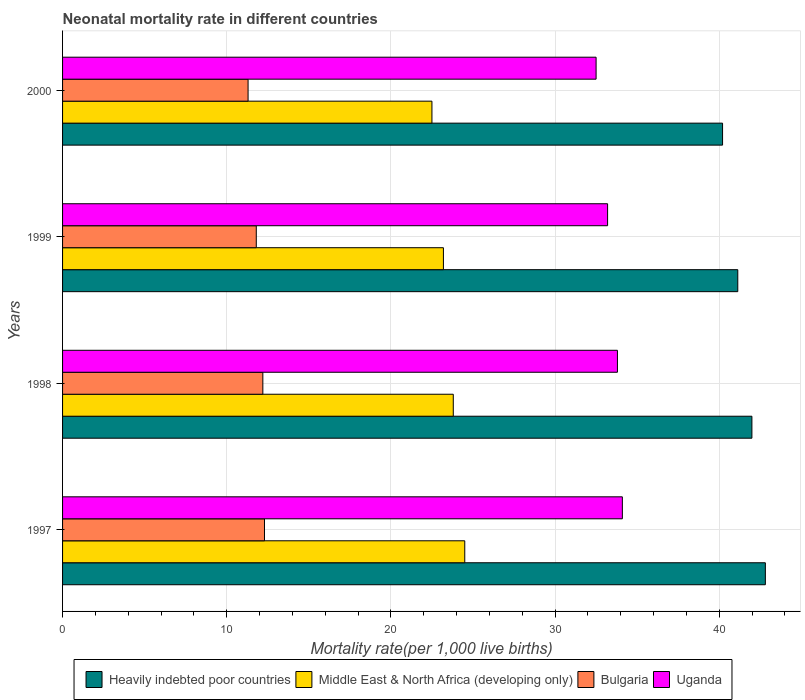Are the number of bars per tick equal to the number of legend labels?
Provide a short and direct response. Yes. Are the number of bars on each tick of the Y-axis equal?
Give a very brief answer. Yes. How many bars are there on the 2nd tick from the top?
Your answer should be compact. 4. How many bars are there on the 1st tick from the bottom?
Your answer should be compact. 4. What is the label of the 1st group of bars from the top?
Offer a terse response. 2000. What is the neonatal mortality rate in Middle East & North Africa (developing only) in 1999?
Make the answer very short. 23.2. Across all years, what is the maximum neonatal mortality rate in Heavily indebted poor countries?
Your answer should be very brief. 42.81. Across all years, what is the minimum neonatal mortality rate in Uganda?
Provide a succinct answer. 32.5. What is the total neonatal mortality rate in Middle East & North Africa (developing only) in the graph?
Ensure brevity in your answer.  94. What is the difference between the neonatal mortality rate in Heavily indebted poor countries in 1997 and that in 1999?
Offer a very short reply. 1.68. What is the difference between the neonatal mortality rate in Middle East & North Africa (developing only) in 1997 and the neonatal mortality rate in Bulgaria in 1999?
Provide a succinct answer. 12.7. What is the average neonatal mortality rate in Middle East & North Africa (developing only) per year?
Your answer should be very brief. 23.5. What is the ratio of the neonatal mortality rate in Middle East & North Africa (developing only) in 1997 to that in 1998?
Your answer should be very brief. 1.03. Is the difference between the neonatal mortality rate in Middle East & North Africa (developing only) in 1998 and 2000 greater than the difference between the neonatal mortality rate in Bulgaria in 1998 and 2000?
Your answer should be compact. Yes. What is the difference between the highest and the second highest neonatal mortality rate in Heavily indebted poor countries?
Your response must be concise. 0.82. What is the difference between the highest and the lowest neonatal mortality rate in Bulgaria?
Make the answer very short. 1. In how many years, is the neonatal mortality rate in Middle East & North Africa (developing only) greater than the average neonatal mortality rate in Middle East & North Africa (developing only) taken over all years?
Offer a terse response. 2. What does the 2nd bar from the top in 1997 represents?
Ensure brevity in your answer.  Bulgaria. What does the 1st bar from the bottom in 2000 represents?
Your answer should be compact. Heavily indebted poor countries. How many bars are there?
Provide a short and direct response. 16. What is the difference between two consecutive major ticks on the X-axis?
Offer a terse response. 10. Does the graph contain grids?
Ensure brevity in your answer.  Yes. Where does the legend appear in the graph?
Make the answer very short. Bottom center. How are the legend labels stacked?
Your answer should be compact. Horizontal. What is the title of the graph?
Your answer should be compact. Neonatal mortality rate in different countries. What is the label or title of the X-axis?
Make the answer very short. Mortality rate(per 1,0 live births). What is the label or title of the Y-axis?
Provide a short and direct response. Years. What is the Mortality rate(per 1,000 live births) of Heavily indebted poor countries in 1997?
Offer a very short reply. 42.81. What is the Mortality rate(per 1,000 live births) of Middle East & North Africa (developing only) in 1997?
Offer a terse response. 24.5. What is the Mortality rate(per 1,000 live births) of Bulgaria in 1997?
Your response must be concise. 12.3. What is the Mortality rate(per 1,000 live births) of Uganda in 1997?
Provide a short and direct response. 34.1. What is the Mortality rate(per 1,000 live births) of Heavily indebted poor countries in 1998?
Your response must be concise. 41.99. What is the Mortality rate(per 1,000 live births) of Middle East & North Africa (developing only) in 1998?
Offer a very short reply. 23.8. What is the Mortality rate(per 1,000 live births) in Uganda in 1998?
Give a very brief answer. 33.8. What is the Mortality rate(per 1,000 live births) in Heavily indebted poor countries in 1999?
Your answer should be compact. 41.13. What is the Mortality rate(per 1,000 live births) in Middle East & North Africa (developing only) in 1999?
Your response must be concise. 23.2. What is the Mortality rate(per 1,000 live births) of Bulgaria in 1999?
Offer a very short reply. 11.8. What is the Mortality rate(per 1,000 live births) in Uganda in 1999?
Give a very brief answer. 33.2. What is the Mortality rate(per 1,000 live births) in Heavily indebted poor countries in 2000?
Your answer should be compact. 40.2. What is the Mortality rate(per 1,000 live births) of Middle East & North Africa (developing only) in 2000?
Provide a succinct answer. 22.5. What is the Mortality rate(per 1,000 live births) of Uganda in 2000?
Provide a short and direct response. 32.5. Across all years, what is the maximum Mortality rate(per 1,000 live births) of Heavily indebted poor countries?
Your answer should be very brief. 42.81. Across all years, what is the maximum Mortality rate(per 1,000 live births) of Uganda?
Ensure brevity in your answer.  34.1. Across all years, what is the minimum Mortality rate(per 1,000 live births) in Heavily indebted poor countries?
Give a very brief answer. 40.2. Across all years, what is the minimum Mortality rate(per 1,000 live births) of Bulgaria?
Provide a succinct answer. 11.3. Across all years, what is the minimum Mortality rate(per 1,000 live births) in Uganda?
Ensure brevity in your answer.  32.5. What is the total Mortality rate(per 1,000 live births) in Heavily indebted poor countries in the graph?
Offer a terse response. 166.14. What is the total Mortality rate(per 1,000 live births) in Middle East & North Africa (developing only) in the graph?
Your answer should be very brief. 94. What is the total Mortality rate(per 1,000 live births) in Bulgaria in the graph?
Keep it short and to the point. 47.6. What is the total Mortality rate(per 1,000 live births) of Uganda in the graph?
Provide a short and direct response. 133.6. What is the difference between the Mortality rate(per 1,000 live births) of Heavily indebted poor countries in 1997 and that in 1998?
Ensure brevity in your answer.  0.82. What is the difference between the Mortality rate(per 1,000 live births) of Bulgaria in 1997 and that in 1998?
Provide a short and direct response. 0.1. What is the difference between the Mortality rate(per 1,000 live births) of Uganda in 1997 and that in 1998?
Offer a very short reply. 0.3. What is the difference between the Mortality rate(per 1,000 live births) of Heavily indebted poor countries in 1997 and that in 1999?
Provide a succinct answer. 1.68. What is the difference between the Mortality rate(per 1,000 live births) in Uganda in 1997 and that in 1999?
Your answer should be very brief. 0.9. What is the difference between the Mortality rate(per 1,000 live births) of Heavily indebted poor countries in 1997 and that in 2000?
Provide a short and direct response. 2.61. What is the difference between the Mortality rate(per 1,000 live births) in Middle East & North Africa (developing only) in 1997 and that in 2000?
Provide a short and direct response. 2. What is the difference between the Mortality rate(per 1,000 live births) of Heavily indebted poor countries in 1998 and that in 1999?
Offer a very short reply. 0.86. What is the difference between the Mortality rate(per 1,000 live births) of Heavily indebted poor countries in 1998 and that in 2000?
Your response must be concise. 1.79. What is the difference between the Mortality rate(per 1,000 live births) of Middle East & North Africa (developing only) in 1998 and that in 2000?
Offer a very short reply. 1.3. What is the difference between the Mortality rate(per 1,000 live births) of Heavily indebted poor countries in 1999 and that in 2000?
Provide a short and direct response. 0.93. What is the difference between the Mortality rate(per 1,000 live births) in Uganda in 1999 and that in 2000?
Provide a succinct answer. 0.7. What is the difference between the Mortality rate(per 1,000 live births) of Heavily indebted poor countries in 1997 and the Mortality rate(per 1,000 live births) of Middle East & North Africa (developing only) in 1998?
Provide a succinct answer. 19.01. What is the difference between the Mortality rate(per 1,000 live births) in Heavily indebted poor countries in 1997 and the Mortality rate(per 1,000 live births) in Bulgaria in 1998?
Offer a very short reply. 30.61. What is the difference between the Mortality rate(per 1,000 live births) of Heavily indebted poor countries in 1997 and the Mortality rate(per 1,000 live births) of Uganda in 1998?
Offer a terse response. 9.01. What is the difference between the Mortality rate(per 1,000 live births) of Bulgaria in 1997 and the Mortality rate(per 1,000 live births) of Uganda in 1998?
Your answer should be compact. -21.5. What is the difference between the Mortality rate(per 1,000 live births) of Heavily indebted poor countries in 1997 and the Mortality rate(per 1,000 live births) of Middle East & North Africa (developing only) in 1999?
Provide a succinct answer. 19.61. What is the difference between the Mortality rate(per 1,000 live births) of Heavily indebted poor countries in 1997 and the Mortality rate(per 1,000 live births) of Bulgaria in 1999?
Provide a succinct answer. 31.01. What is the difference between the Mortality rate(per 1,000 live births) in Heavily indebted poor countries in 1997 and the Mortality rate(per 1,000 live births) in Uganda in 1999?
Keep it short and to the point. 9.61. What is the difference between the Mortality rate(per 1,000 live births) in Middle East & North Africa (developing only) in 1997 and the Mortality rate(per 1,000 live births) in Uganda in 1999?
Keep it short and to the point. -8.7. What is the difference between the Mortality rate(per 1,000 live births) of Bulgaria in 1997 and the Mortality rate(per 1,000 live births) of Uganda in 1999?
Offer a very short reply. -20.9. What is the difference between the Mortality rate(per 1,000 live births) in Heavily indebted poor countries in 1997 and the Mortality rate(per 1,000 live births) in Middle East & North Africa (developing only) in 2000?
Offer a very short reply. 20.31. What is the difference between the Mortality rate(per 1,000 live births) of Heavily indebted poor countries in 1997 and the Mortality rate(per 1,000 live births) of Bulgaria in 2000?
Your answer should be very brief. 31.51. What is the difference between the Mortality rate(per 1,000 live births) of Heavily indebted poor countries in 1997 and the Mortality rate(per 1,000 live births) of Uganda in 2000?
Offer a terse response. 10.31. What is the difference between the Mortality rate(per 1,000 live births) in Middle East & North Africa (developing only) in 1997 and the Mortality rate(per 1,000 live births) in Bulgaria in 2000?
Your answer should be compact. 13.2. What is the difference between the Mortality rate(per 1,000 live births) in Bulgaria in 1997 and the Mortality rate(per 1,000 live births) in Uganda in 2000?
Offer a very short reply. -20.2. What is the difference between the Mortality rate(per 1,000 live births) of Heavily indebted poor countries in 1998 and the Mortality rate(per 1,000 live births) of Middle East & North Africa (developing only) in 1999?
Keep it short and to the point. 18.79. What is the difference between the Mortality rate(per 1,000 live births) in Heavily indebted poor countries in 1998 and the Mortality rate(per 1,000 live births) in Bulgaria in 1999?
Provide a short and direct response. 30.19. What is the difference between the Mortality rate(per 1,000 live births) of Heavily indebted poor countries in 1998 and the Mortality rate(per 1,000 live births) of Uganda in 1999?
Your response must be concise. 8.79. What is the difference between the Mortality rate(per 1,000 live births) in Middle East & North Africa (developing only) in 1998 and the Mortality rate(per 1,000 live births) in Bulgaria in 1999?
Your answer should be very brief. 12. What is the difference between the Mortality rate(per 1,000 live births) in Bulgaria in 1998 and the Mortality rate(per 1,000 live births) in Uganda in 1999?
Your answer should be compact. -21. What is the difference between the Mortality rate(per 1,000 live births) in Heavily indebted poor countries in 1998 and the Mortality rate(per 1,000 live births) in Middle East & North Africa (developing only) in 2000?
Your answer should be very brief. 19.49. What is the difference between the Mortality rate(per 1,000 live births) of Heavily indebted poor countries in 1998 and the Mortality rate(per 1,000 live births) of Bulgaria in 2000?
Your answer should be very brief. 30.69. What is the difference between the Mortality rate(per 1,000 live births) in Heavily indebted poor countries in 1998 and the Mortality rate(per 1,000 live births) in Uganda in 2000?
Make the answer very short. 9.49. What is the difference between the Mortality rate(per 1,000 live births) of Bulgaria in 1998 and the Mortality rate(per 1,000 live births) of Uganda in 2000?
Offer a terse response. -20.3. What is the difference between the Mortality rate(per 1,000 live births) of Heavily indebted poor countries in 1999 and the Mortality rate(per 1,000 live births) of Middle East & North Africa (developing only) in 2000?
Your answer should be very brief. 18.63. What is the difference between the Mortality rate(per 1,000 live births) of Heavily indebted poor countries in 1999 and the Mortality rate(per 1,000 live births) of Bulgaria in 2000?
Your answer should be very brief. 29.83. What is the difference between the Mortality rate(per 1,000 live births) in Heavily indebted poor countries in 1999 and the Mortality rate(per 1,000 live births) in Uganda in 2000?
Keep it short and to the point. 8.63. What is the difference between the Mortality rate(per 1,000 live births) of Bulgaria in 1999 and the Mortality rate(per 1,000 live births) of Uganda in 2000?
Give a very brief answer. -20.7. What is the average Mortality rate(per 1,000 live births) of Heavily indebted poor countries per year?
Provide a short and direct response. 41.53. What is the average Mortality rate(per 1,000 live births) in Bulgaria per year?
Offer a terse response. 11.9. What is the average Mortality rate(per 1,000 live births) of Uganda per year?
Provide a succinct answer. 33.4. In the year 1997, what is the difference between the Mortality rate(per 1,000 live births) of Heavily indebted poor countries and Mortality rate(per 1,000 live births) of Middle East & North Africa (developing only)?
Keep it short and to the point. 18.31. In the year 1997, what is the difference between the Mortality rate(per 1,000 live births) of Heavily indebted poor countries and Mortality rate(per 1,000 live births) of Bulgaria?
Your answer should be very brief. 30.51. In the year 1997, what is the difference between the Mortality rate(per 1,000 live births) in Heavily indebted poor countries and Mortality rate(per 1,000 live births) in Uganda?
Provide a succinct answer. 8.71. In the year 1997, what is the difference between the Mortality rate(per 1,000 live births) in Bulgaria and Mortality rate(per 1,000 live births) in Uganda?
Your response must be concise. -21.8. In the year 1998, what is the difference between the Mortality rate(per 1,000 live births) of Heavily indebted poor countries and Mortality rate(per 1,000 live births) of Middle East & North Africa (developing only)?
Offer a terse response. 18.19. In the year 1998, what is the difference between the Mortality rate(per 1,000 live births) of Heavily indebted poor countries and Mortality rate(per 1,000 live births) of Bulgaria?
Your answer should be compact. 29.79. In the year 1998, what is the difference between the Mortality rate(per 1,000 live births) of Heavily indebted poor countries and Mortality rate(per 1,000 live births) of Uganda?
Keep it short and to the point. 8.19. In the year 1998, what is the difference between the Mortality rate(per 1,000 live births) in Bulgaria and Mortality rate(per 1,000 live births) in Uganda?
Keep it short and to the point. -21.6. In the year 1999, what is the difference between the Mortality rate(per 1,000 live births) of Heavily indebted poor countries and Mortality rate(per 1,000 live births) of Middle East & North Africa (developing only)?
Offer a very short reply. 17.93. In the year 1999, what is the difference between the Mortality rate(per 1,000 live births) in Heavily indebted poor countries and Mortality rate(per 1,000 live births) in Bulgaria?
Ensure brevity in your answer.  29.33. In the year 1999, what is the difference between the Mortality rate(per 1,000 live births) in Heavily indebted poor countries and Mortality rate(per 1,000 live births) in Uganda?
Your response must be concise. 7.93. In the year 1999, what is the difference between the Mortality rate(per 1,000 live births) of Middle East & North Africa (developing only) and Mortality rate(per 1,000 live births) of Uganda?
Your response must be concise. -10. In the year 1999, what is the difference between the Mortality rate(per 1,000 live births) of Bulgaria and Mortality rate(per 1,000 live births) of Uganda?
Your answer should be compact. -21.4. In the year 2000, what is the difference between the Mortality rate(per 1,000 live births) of Heavily indebted poor countries and Mortality rate(per 1,000 live births) of Middle East & North Africa (developing only)?
Keep it short and to the point. 17.7. In the year 2000, what is the difference between the Mortality rate(per 1,000 live births) of Heavily indebted poor countries and Mortality rate(per 1,000 live births) of Bulgaria?
Keep it short and to the point. 28.9. In the year 2000, what is the difference between the Mortality rate(per 1,000 live births) of Heavily indebted poor countries and Mortality rate(per 1,000 live births) of Uganda?
Offer a terse response. 7.7. In the year 2000, what is the difference between the Mortality rate(per 1,000 live births) in Bulgaria and Mortality rate(per 1,000 live births) in Uganda?
Offer a terse response. -21.2. What is the ratio of the Mortality rate(per 1,000 live births) in Heavily indebted poor countries in 1997 to that in 1998?
Your response must be concise. 1.02. What is the ratio of the Mortality rate(per 1,000 live births) of Middle East & North Africa (developing only) in 1997 to that in 1998?
Ensure brevity in your answer.  1.03. What is the ratio of the Mortality rate(per 1,000 live births) of Bulgaria in 1997 to that in 1998?
Your answer should be very brief. 1.01. What is the ratio of the Mortality rate(per 1,000 live births) of Uganda in 1997 to that in 1998?
Your answer should be very brief. 1.01. What is the ratio of the Mortality rate(per 1,000 live births) in Heavily indebted poor countries in 1997 to that in 1999?
Ensure brevity in your answer.  1.04. What is the ratio of the Mortality rate(per 1,000 live births) of Middle East & North Africa (developing only) in 1997 to that in 1999?
Provide a short and direct response. 1.06. What is the ratio of the Mortality rate(per 1,000 live births) in Bulgaria in 1997 to that in 1999?
Ensure brevity in your answer.  1.04. What is the ratio of the Mortality rate(per 1,000 live births) of Uganda in 1997 to that in 1999?
Your response must be concise. 1.03. What is the ratio of the Mortality rate(per 1,000 live births) in Heavily indebted poor countries in 1997 to that in 2000?
Your response must be concise. 1.06. What is the ratio of the Mortality rate(per 1,000 live births) of Middle East & North Africa (developing only) in 1997 to that in 2000?
Your response must be concise. 1.09. What is the ratio of the Mortality rate(per 1,000 live births) of Bulgaria in 1997 to that in 2000?
Offer a terse response. 1.09. What is the ratio of the Mortality rate(per 1,000 live births) in Uganda in 1997 to that in 2000?
Provide a succinct answer. 1.05. What is the ratio of the Mortality rate(per 1,000 live births) of Heavily indebted poor countries in 1998 to that in 1999?
Offer a terse response. 1.02. What is the ratio of the Mortality rate(per 1,000 live births) in Middle East & North Africa (developing only) in 1998 to that in 1999?
Offer a very short reply. 1.03. What is the ratio of the Mortality rate(per 1,000 live births) in Bulgaria in 1998 to that in 1999?
Offer a terse response. 1.03. What is the ratio of the Mortality rate(per 1,000 live births) of Uganda in 1998 to that in 1999?
Offer a terse response. 1.02. What is the ratio of the Mortality rate(per 1,000 live births) in Heavily indebted poor countries in 1998 to that in 2000?
Offer a very short reply. 1.04. What is the ratio of the Mortality rate(per 1,000 live births) in Middle East & North Africa (developing only) in 1998 to that in 2000?
Provide a succinct answer. 1.06. What is the ratio of the Mortality rate(per 1,000 live births) of Bulgaria in 1998 to that in 2000?
Offer a terse response. 1.08. What is the ratio of the Mortality rate(per 1,000 live births) in Heavily indebted poor countries in 1999 to that in 2000?
Your answer should be very brief. 1.02. What is the ratio of the Mortality rate(per 1,000 live births) in Middle East & North Africa (developing only) in 1999 to that in 2000?
Your answer should be compact. 1.03. What is the ratio of the Mortality rate(per 1,000 live births) in Bulgaria in 1999 to that in 2000?
Give a very brief answer. 1.04. What is the ratio of the Mortality rate(per 1,000 live births) of Uganda in 1999 to that in 2000?
Your answer should be compact. 1.02. What is the difference between the highest and the second highest Mortality rate(per 1,000 live births) in Heavily indebted poor countries?
Keep it short and to the point. 0.82. What is the difference between the highest and the second highest Mortality rate(per 1,000 live births) of Middle East & North Africa (developing only)?
Offer a terse response. 0.7. What is the difference between the highest and the second highest Mortality rate(per 1,000 live births) of Bulgaria?
Ensure brevity in your answer.  0.1. What is the difference between the highest and the second highest Mortality rate(per 1,000 live births) in Uganda?
Ensure brevity in your answer.  0.3. What is the difference between the highest and the lowest Mortality rate(per 1,000 live births) of Heavily indebted poor countries?
Your response must be concise. 2.61. What is the difference between the highest and the lowest Mortality rate(per 1,000 live births) of Bulgaria?
Your answer should be compact. 1. What is the difference between the highest and the lowest Mortality rate(per 1,000 live births) in Uganda?
Offer a terse response. 1.6. 